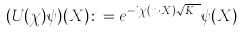Convert formula to latex. <formula><loc_0><loc_0><loc_500><loc_500>( U ( \chi ) \psi ) ( X ) \colon = e ^ { - i \chi ( n \cdot X ) \sqrt { K _ { n } } } \psi ( X )</formula> 